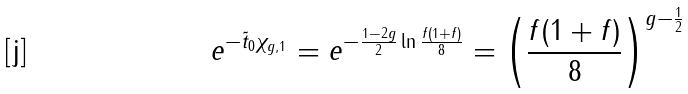Convert formula to latex. <formula><loc_0><loc_0><loc_500><loc_500>e ^ { - \tilde { t } _ { 0 } \chi _ { g , 1 } } = e ^ { - \frac { 1 - 2 g } { 2 } \ln \frac { f ( 1 + f ) } { 8 } } = \left ( \frac { f ( 1 + f ) } { 8 } \right ) ^ { g - \frac { 1 } { 2 } }</formula> 